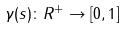<formula> <loc_0><loc_0><loc_500><loc_500>\gamma ( s ) \colon R ^ { + } \rightarrow [ 0 , 1 ]</formula> 